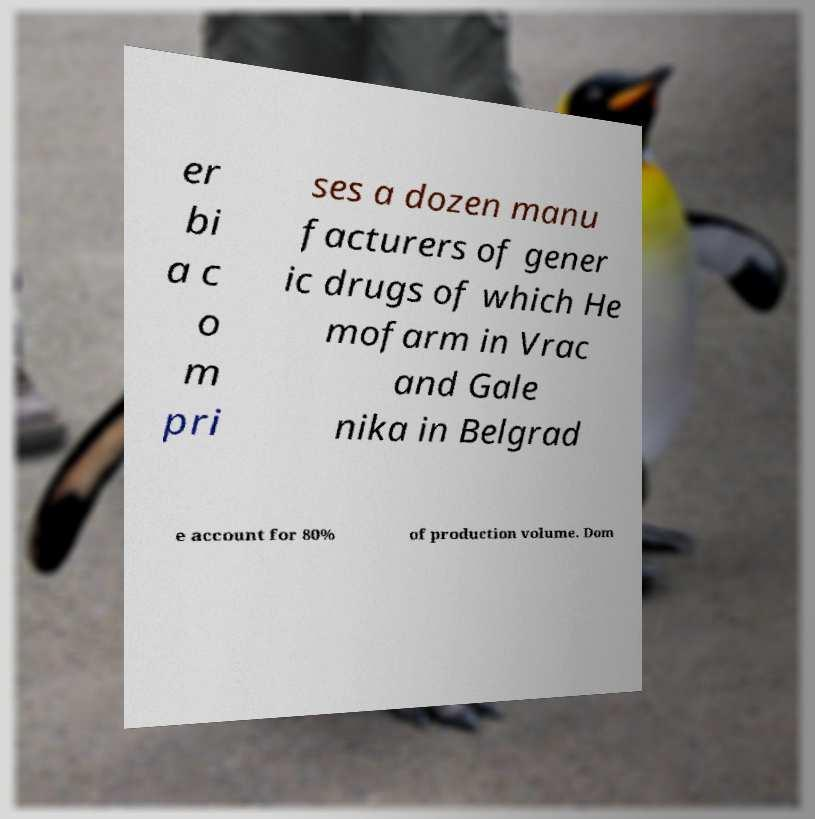There's text embedded in this image that I need extracted. Can you transcribe it verbatim? er bi a c o m pri ses a dozen manu facturers of gener ic drugs of which He mofarm in Vrac and Gale nika in Belgrad e account for 80% of production volume. Dom 